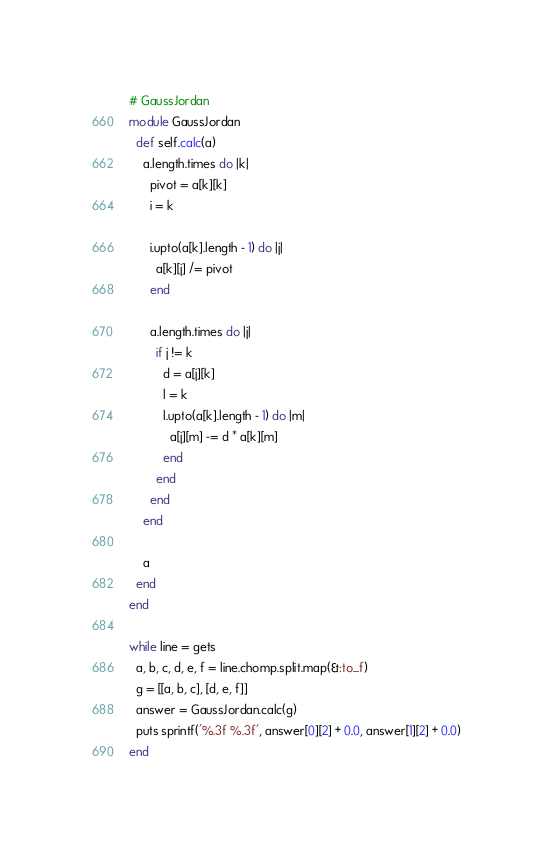Convert code to text. <code><loc_0><loc_0><loc_500><loc_500><_Ruby_># GaussJordan
module GaussJordan
  def self.calc(a)
    a.length.times do |k|
      pivot = a[k][k]
      i = k

      i.upto(a[k].length - 1) do |j|
        a[k][j] /= pivot
      end

      a.length.times do |j|
        if j != k
          d = a[j][k]
          l = k
          l.upto(a[k].length - 1) do |m|
            a[j][m] -= d * a[k][m]
          end
        end
      end
    end

    a
  end
end

while line = gets
  a, b, c, d, e, f = line.chomp.split.map(&:to_f)
  g = [[a, b, c], [d, e, f]]
  answer = GaussJordan.calc(g)
  puts sprintf('%.3f %.3f', answer[0][2] + 0.0, answer[1][2] + 0.0)
end</code> 